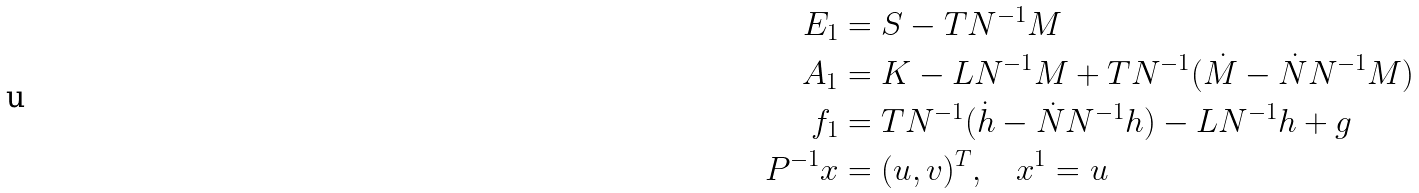<formula> <loc_0><loc_0><loc_500><loc_500>E _ { 1 } & = S - T N ^ { - 1 } M \\ A _ { 1 } & = K - L N ^ { - 1 } M + T N ^ { - 1 } ( \dot { M } - \dot { N } N ^ { - 1 } M ) \\ f _ { 1 } & = T N ^ { - 1 } ( \dot { h } - \dot { N } N ^ { - 1 } h ) - L N ^ { - 1 } h + g \\ P ^ { - 1 } x & = ( u , v ) ^ { T } , \quad x ^ { 1 } = u</formula> 